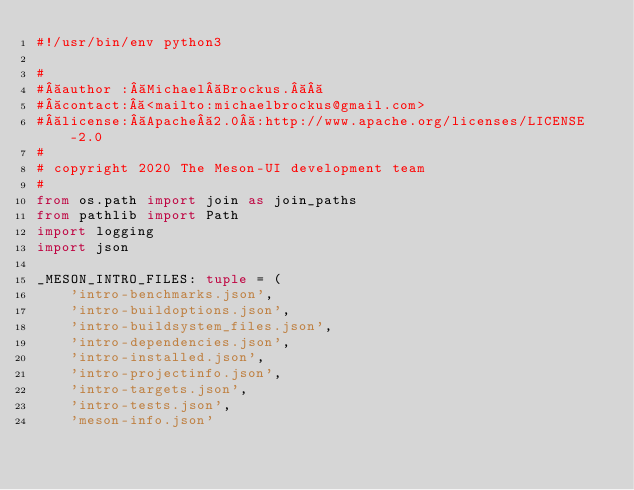Convert code to text. <code><loc_0><loc_0><loc_500><loc_500><_Python_>#!/usr/bin/env python3

#
# author : Michael Brockus.  
# contact: <mailto:michaelbrockus@gmail.com>
# license: Apache 2.0 :http://www.apache.org/licenses/LICENSE-2.0
#
# copyright 2020 The Meson-UI development team
#
from os.path import join as join_paths
from pathlib import Path
import logging
import json

_MESON_INTRO_FILES: tuple = (
    'intro-benchmarks.json',
    'intro-buildoptions.json',
    'intro-buildsystem_files.json',
    'intro-dependencies.json',
    'intro-installed.json',
    'intro-projectinfo.json',
    'intro-targets.json',
    'intro-tests.json',
    'meson-info.json'</code> 